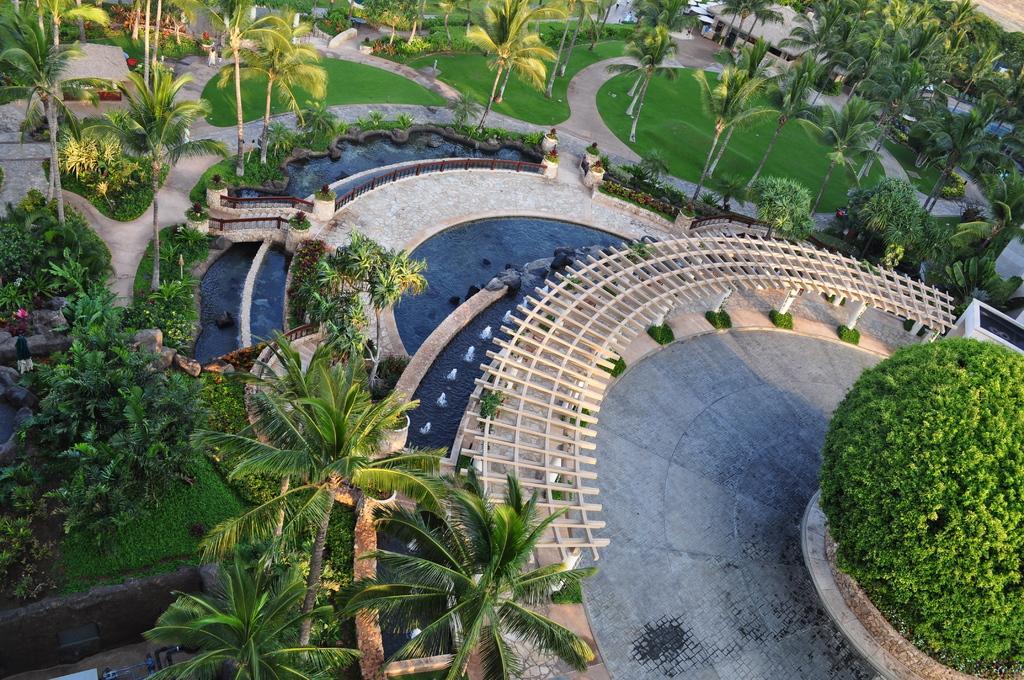How would you summarize this image in a sentence or two? This image is taken outdoors. In this image there is a ground with grass on it and there are a few pavements. There is a fountain with water. There are many trees and plants on the ground. In the middle of the image there is a bridge with railings and there is a big plant in the pot on the right side of the image. 